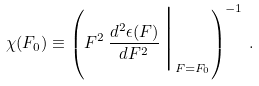<formula> <loc_0><loc_0><loc_500><loc_500>\chi ( F _ { 0 } ) \equiv \left ( F ^ { 2 } \, \frac { d ^ { 2 } \epsilon ( F ) } { d F ^ { 2 } } \, \Big | _ { F = F _ { 0 } } \right ) ^ { - 1 } \, .</formula> 